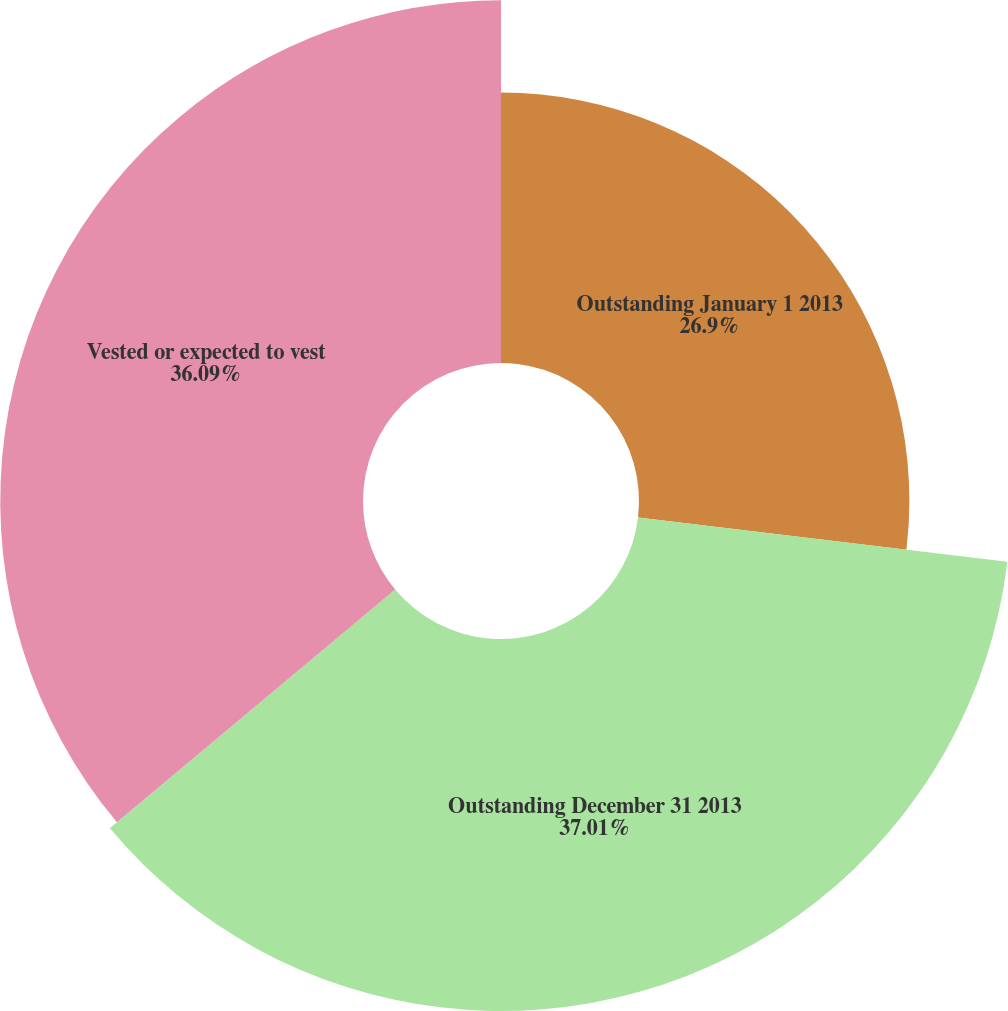<chart> <loc_0><loc_0><loc_500><loc_500><pie_chart><fcel>Outstanding January 1 2013<fcel>Outstanding December 31 2013<fcel>Vested or expected to vest<nl><fcel>26.9%<fcel>37.01%<fcel>36.09%<nl></chart> 